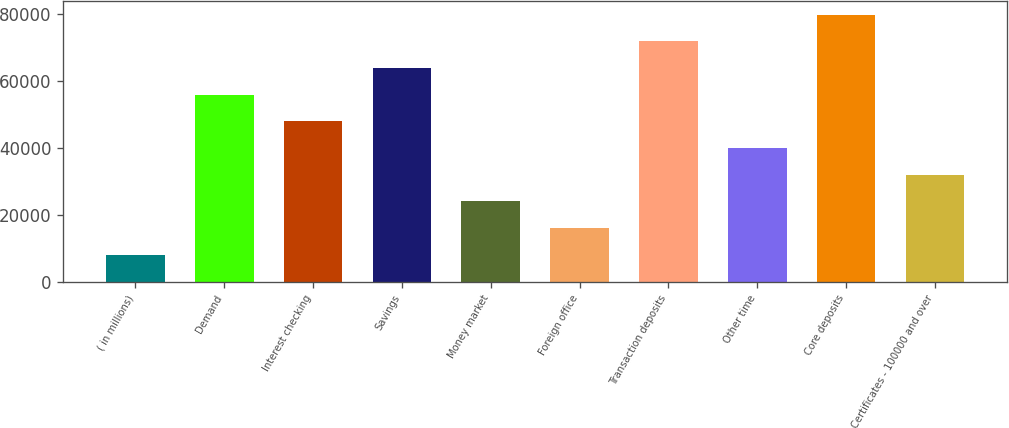Convert chart to OTSL. <chart><loc_0><loc_0><loc_500><loc_500><bar_chart><fcel>( in millions)<fcel>Demand<fcel>Interest checking<fcel>Savings<fcel>Money market<fcel>Foreign office<fcel>Transaction deposits<fcel>Other time<fcel>Core deposits<fcel>Certificates - 100000 and over<nl><fcel>8127.5<fcel>55950.5<fcel>47980<fcel>63921<fcel>24068.5<fcel>16098<fcel>71891.5<fcel>40009.5<fcel>79862<fcel>32039<nl></chart> 